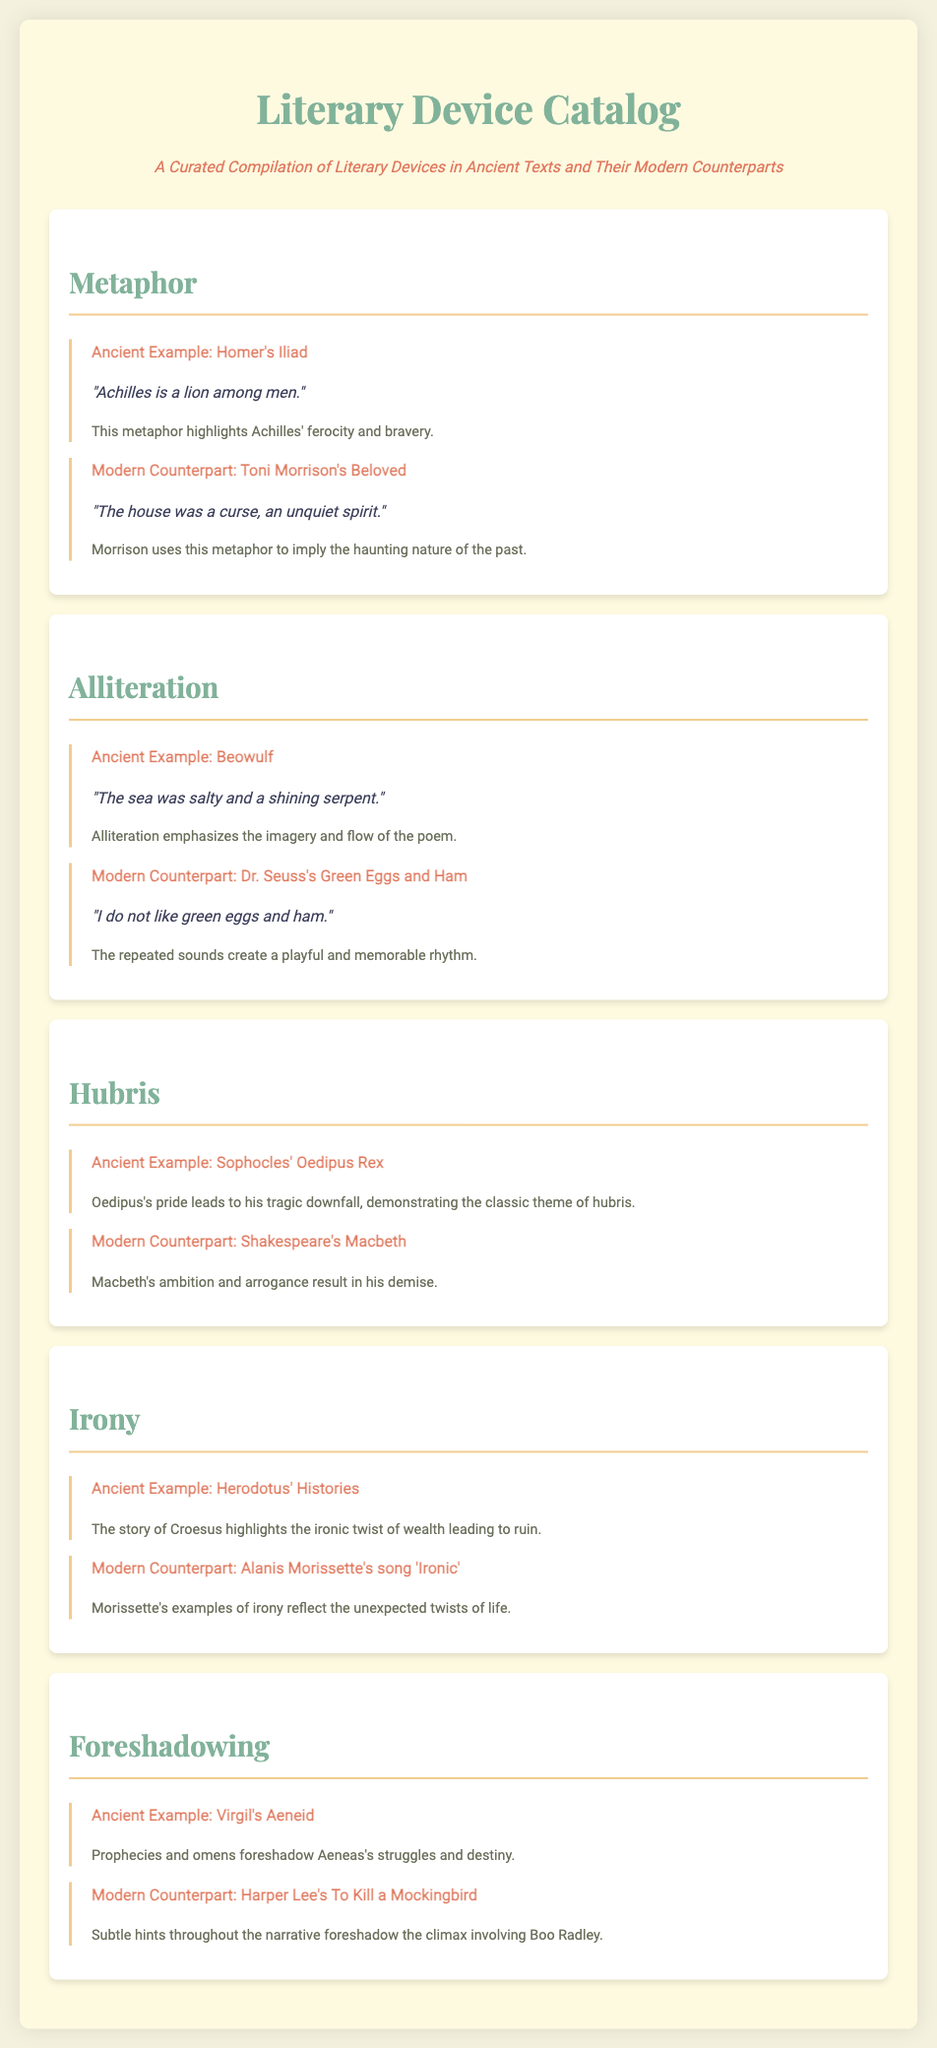What literary device is highlighted in the first section? The first section focuses on metaphors used in ancient and modern literature.
Answer: Metaphor Which ancient text features the example "Achilles is a lion among men"? This metaphor is from Homer's Iliad, illustrating the character of Achilles.
Answer: Homer's Iliad What is the modern counterpart cited for the literary device of foreshadowing? The document mentions Harper Lee's To Kill a Mockingbird as a modern example of foreshadowing.
Answer: To Kill a Mockingbird How is hubris demonstrated in Sophocles' Oedipus Rex? The text notes that Oedipus's pride leads to his tragic downfall, exemplifying hubris.
Answer: Oedipus's pride Which device has an example from Alanis Morissette's song? The song used is 'Ironic,' which illustrates modern expressions of irony.
Answer: Irony What specific literary feature is emphasized through sound in Beowulf? The document states that alliteration is used in the example from Beowulf to enhance imagery.
Answer: Alliteration 